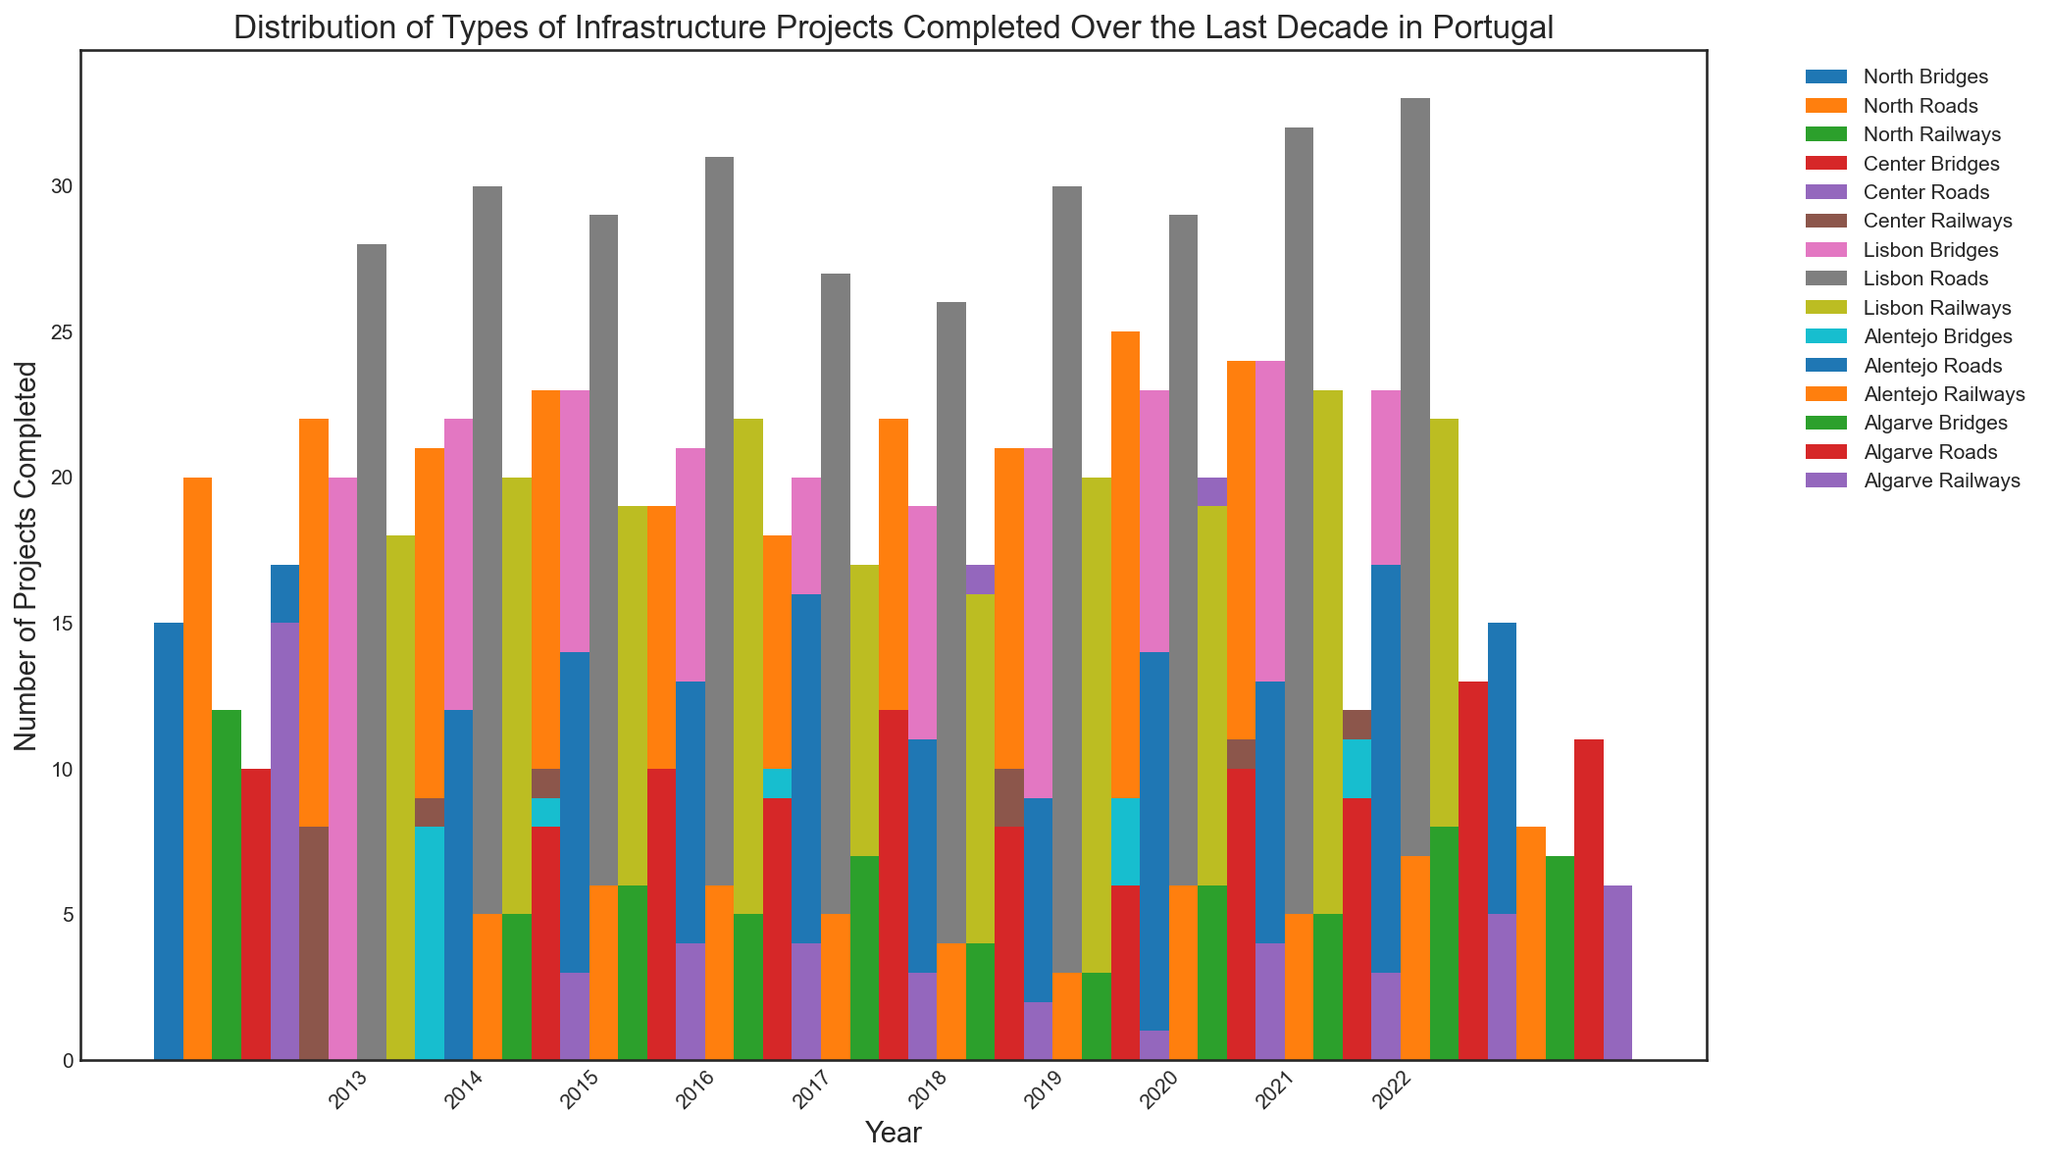What was the total number of bridge projects completed in Lisbon over the decade? Summing up the number of bridge projects in Lisbon from 2013 to 2022: 20 + 22 + 23 + 21 + 20 + 19 + 21 + 23 + 24 + 23 = 216
Answer: 216 Which region completed the most railway projects in 2022? Looking at the values for railways in 2022: North - 17, Center - 12, Lisbon - 22, Alentejo - 8, Algarve - 6; Lisbon has the highest value.
Answer: Lisbon In which year did the Center region complete the highest number of road projects? Reviewing the Center region's road projects data: 15, 17, 16, 19, 15, 13, 17, 16, 20, 18; the highest number is 20 in 2021.
Answer: 2021 Comparing road projects in North and Lisbon regions in 2015, which region had more? Checking road projects data for 2015: North - 21, Lisbon - 29; Lisbon had more road projects.
Answer: Lisbon How many more railway projects were completed in North in 2020 than in Alentejo in the same year? Railway projects in North and Alentejo in 2020 were 13 and 5 respectively. The difference is 13 - 5 = 8
Answer: 8 Which type of project consistently had the least number of completions in Algarve over the decade? Reviewing the projects in Algarve (2013-2022): Bridges - (5, 6, 5, 7, 4, 3, 6, 5, 8, 7), Roads - (8, 10, 9, 12, 8, 6, 10, 9, 13, 11), Railways - (3, 4, 4, 3, 2, 1, 4, 3, 5, 6); Railways consistently had the least number of completions.
Answer: Railways Which year saw the highest total number of infrastructure projects completed in the North region? Summing up all types in North for each year and identifying the highest sum: 
2013 - 47, 2014 - 53, 2015 - 50, 2016 - 57, 2017 - 44, 2018 - 43, 2019 - 53, 2020 - 50, 2021 - 59, 2022 - 61; The highest is 2022 with 61
Answer: 2022 What is the average number of bridges completed per year in the Alentejo region? Summing the bridge projects in Alentejo: 8 + 9 + 8 + 10 + 7 + 6 + 9 + 8 + 11 + 10 = 86; Average is 86 / 10 ≈ 8.6
Answer: 8.6 